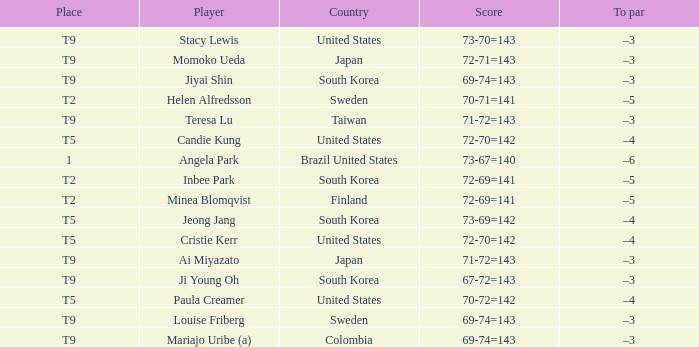What was Momoko Ueda's place? T9. 